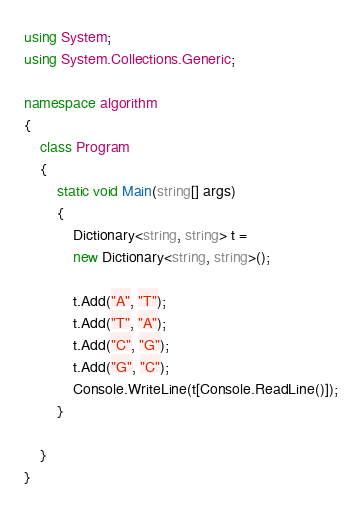Convert code to text. <code><loc_0><loc_0><loc_500><loc_500><_C#_>using System;
using System.Collections.Generic;

namespace algorithm
{
	class Program
	{
		static void Main(string[] args)
		{
			Dictionary<string, string> t =
			new Dictionary<string, string>();

			t.Add("A", "T");
			t.Add("T", "A");
			t.Add("C", "G");
			t.Add("G", "C");
			Console.WriteLine(t[Console.ReadLine()]);
		}

	}
}
</code> 